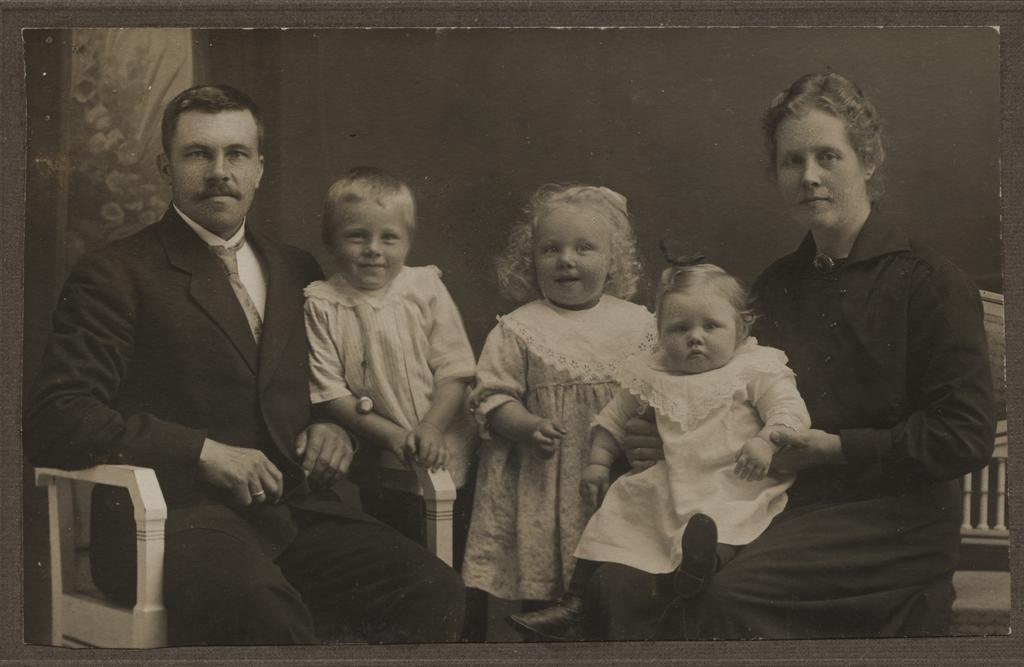Could you give a brief overview of what you see in this image? In the center of the image two kids are standing. On the left side of the image a man is sitting on a chair. On the right side of the image a lady is sitting on a chair and holding a baby. In the background of the image wall is present. 